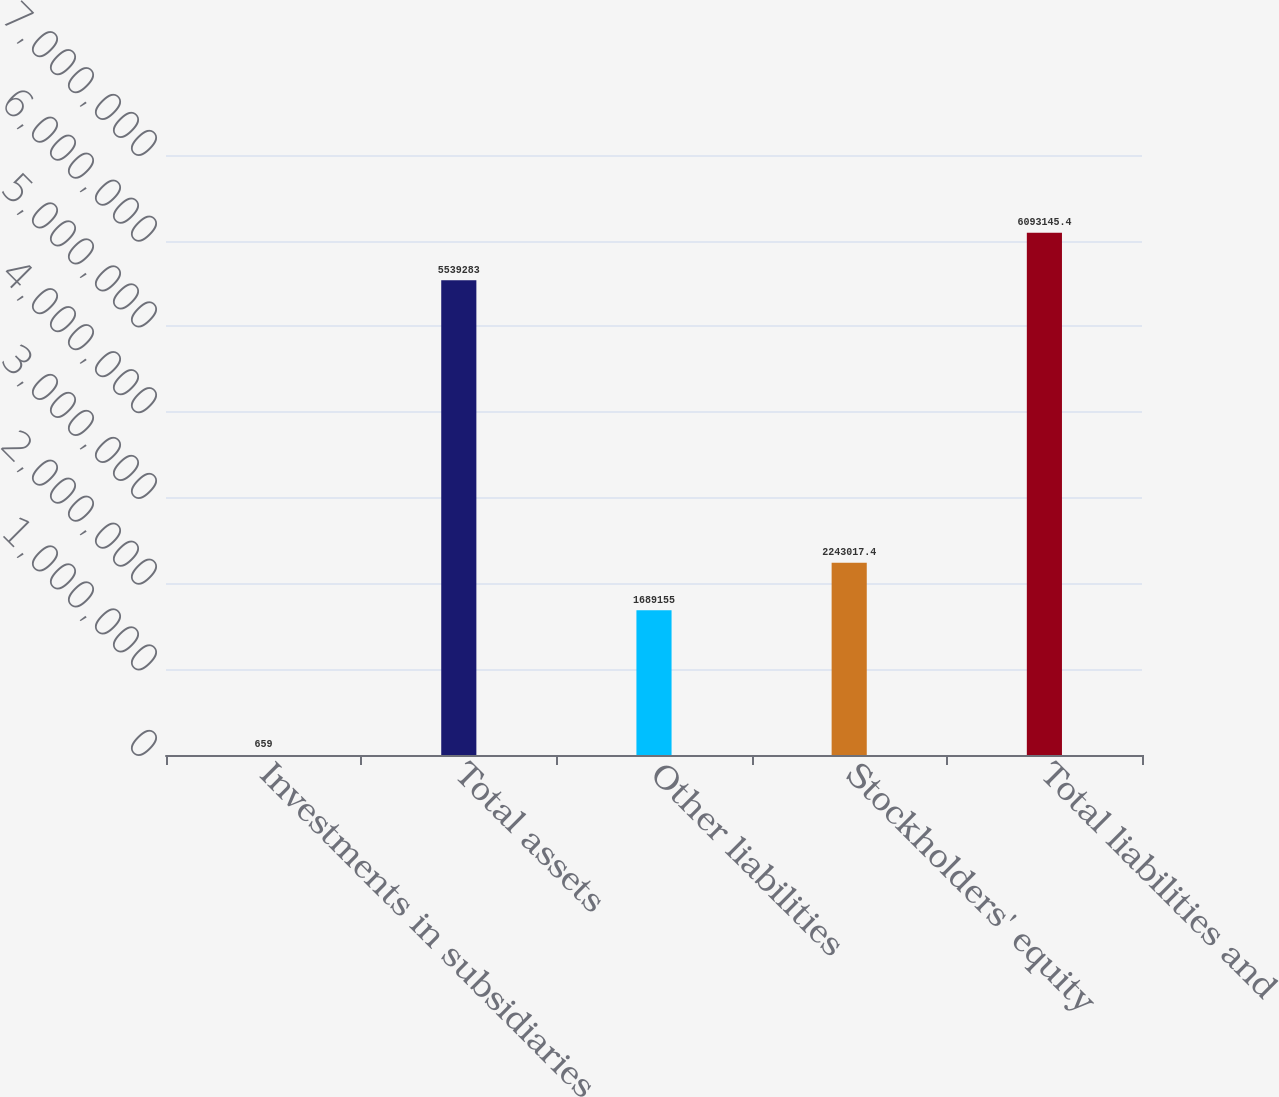Convert chart. <chart><loc_0><loc_0><loc_500><loc_500><bar_chart><fcel>Investments in subsidiaries<fcel>Total assets<fcel>Other liabilities<fcel>Stockholders' equity<fcel>Total liabilities and<nl><fcel>659<fcel>5.53928e+06<fcel>1.68916e+06<fcel>2.24302e+06<fcel>6.09315e+06<nl></chart> 